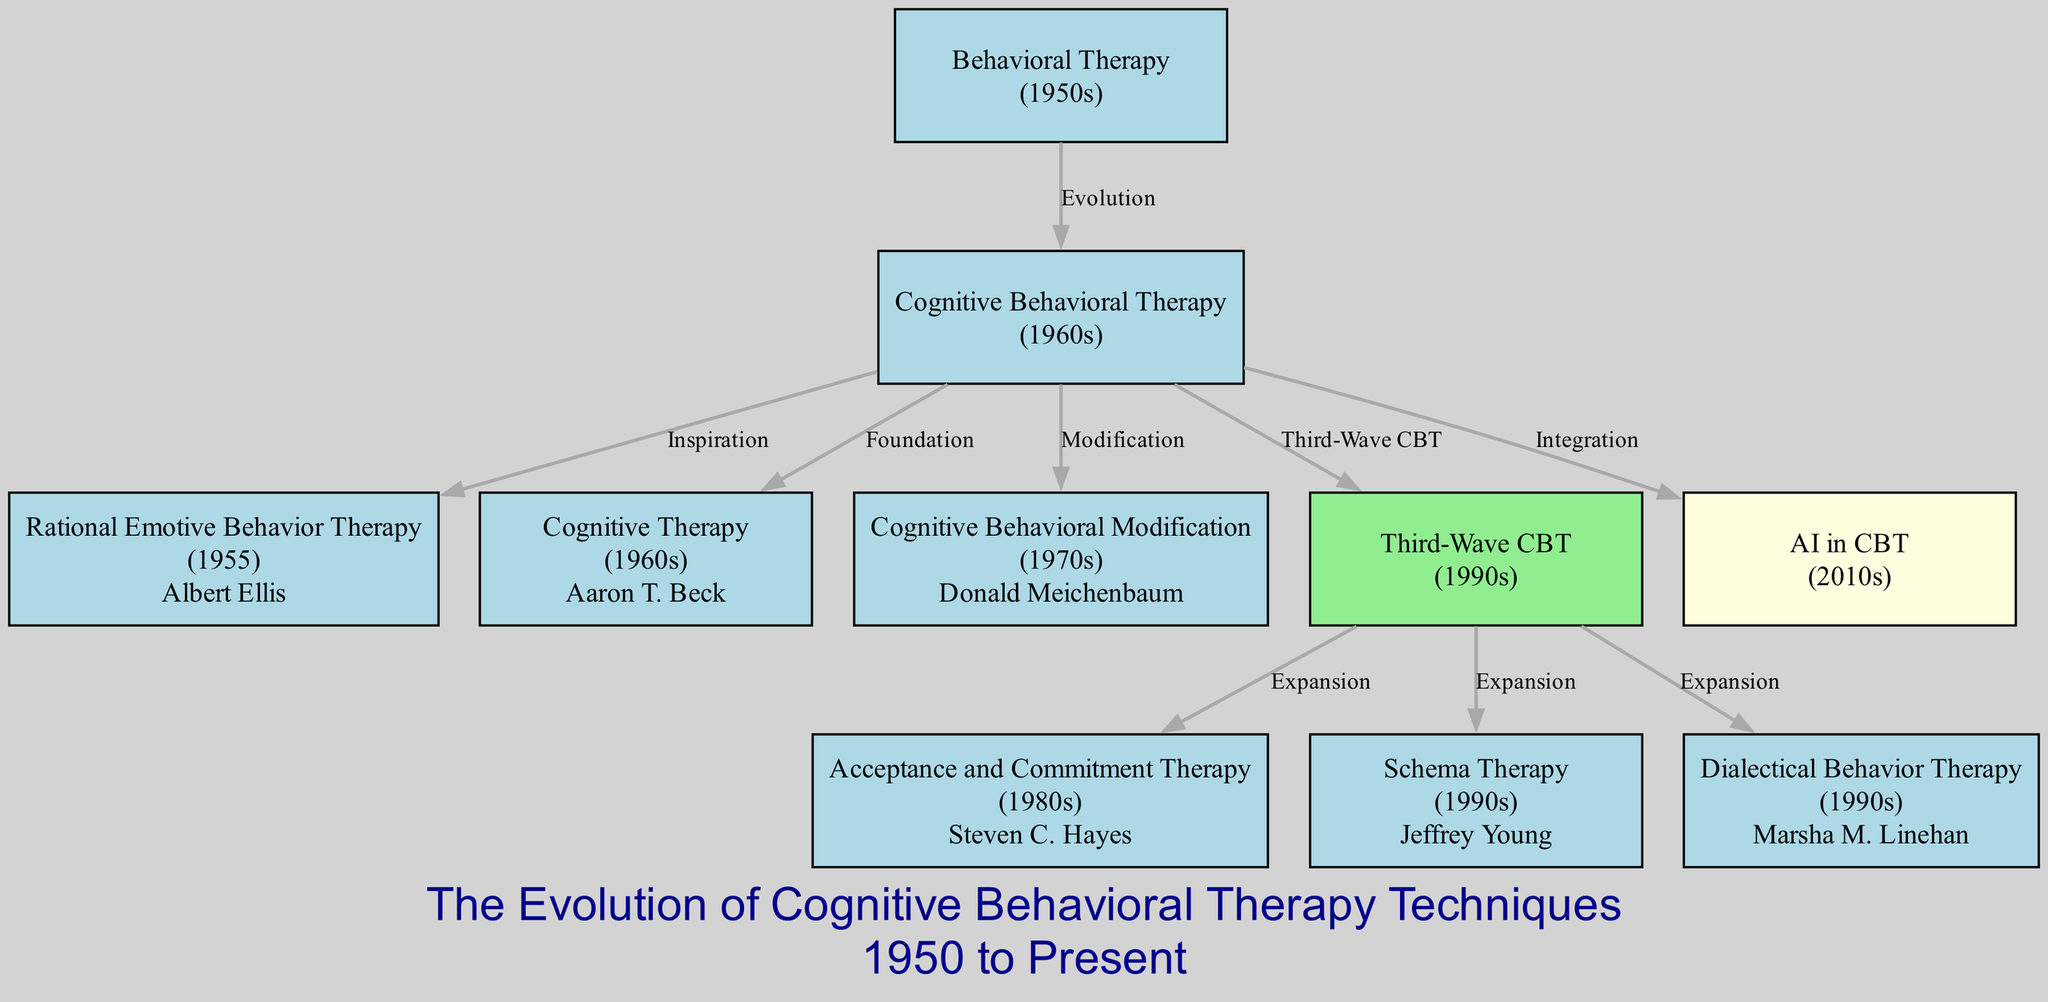What is the earliest technique mentioned in the diagram? The diagram lists "Behavioral Therapy" from the 1950s as the earliest technique. By scanning the nodes, "Behavioral Therapy" is identified as it appears first in the time timeline.
Answer: Behavioral Therapy Who developed Rational Emotive Behavior Therapy? The node for "Rational Emotive Behavior Therapy" specifies Albert Ellis as the theorist. By looking at this specific node, you can find the name associated with this therapy.
Answer: Albert Ellis How many types of therapies are shown from the 1990s? The diagram includes three therapy types from the 1990s: "Third-Wave CBT," "Schema Therapy," and "Dialectical Behavior Therapy." By counting the relevant nodes in the specified decade, you arrive at the number.
Answer: 3 What connects Cognitive Behavioral Therapy and Dialectical Behavior Therapy? The diagram shows "CBT" as a precursor and an influential node that "defines" and connects to "Dialectical Behavior Therapy" through "Third-Wave CBT" as an expanding influence. By tracing the edges, we can see the relationship and paths.
Answer: Third-Wave CBT In which decade does AI in CBT appear? The node for "AI in CBT" is dated in the 2010s as per the diagram. By checking the date listed directly within the node, you identify the time frame it emerged.
Answer: 2010s Which therapy is an expansion of Third-Wave CBT? "Acceptance and Commitment Therapy," "Schema Therapy," and "Dialectical Behavior Therapy" are all shown as expansions of "Third-Wave CBT." By examining the edges coming out of the "Third-Wave CBT" node, all connections can be identified.
Answer: Acceptance and Commitment Therapy What is the relationship labeled between Cognitive Behavioral Therapy and Cognitive Behavioral Modification? The edge between "CBT" and "Cognitive Behavioral Modification" is labeled as "Modification." By identifying the connecting edge in the diagram and reading its label, the relationship can be established.
Answer: Modification How many total nodes are present in the diagram? The diagram features 10 distinct nodes representing different therapies or CBT-related concepts. By simply counting the entries from the listed nodes, the total count is determined.
Answer: 10 What influence did Rational Emotive Behavior Therapy have on Cognitive Behavioral Therapy? The relationship is labeled "Inspiration," indicating that "Rational Emotive Behavior Therapy" served as a source of influence for the development of "Cognitive Behavioral Therapy." This can be inferred by examining the edge label connecting the two nodes.
Answer: Inspiration 